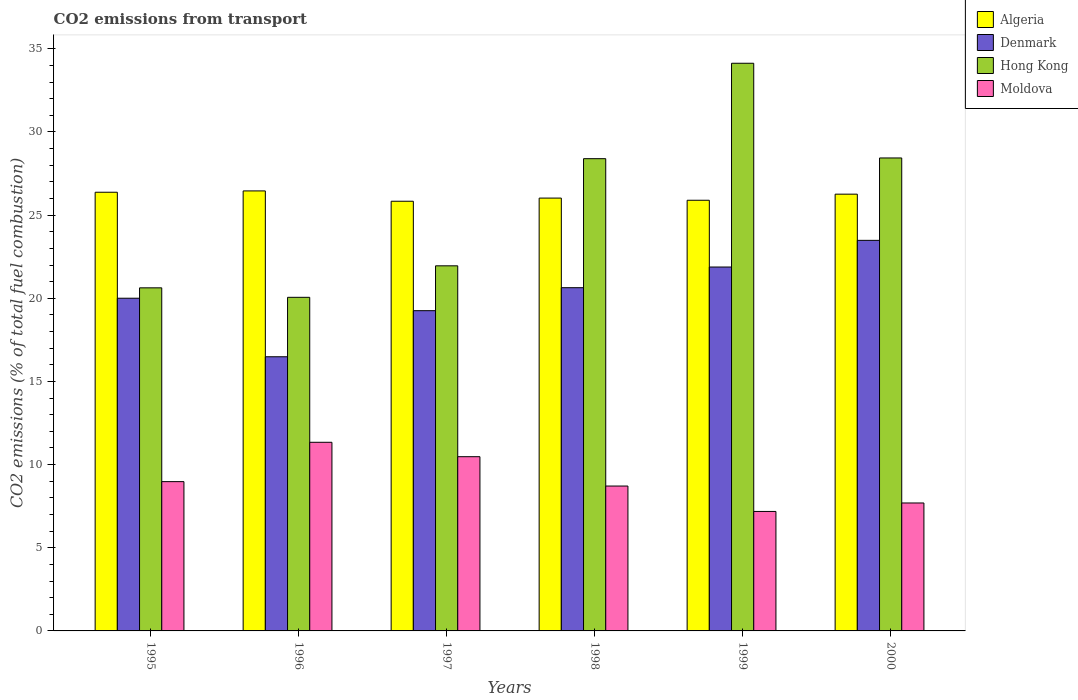How many groups of bars are there?
Your response must be concise. 6. What is the label of the 2nd group of bars from the left?
Offer a terse response. 1996. What is the total CO2 emitted in Algeria in 1999?
Your response must be concise. 25.89. Across all years, what is the maximum total CO2 emitted in Moldova?
Give a very brief answer. 11.34. Across all years, what is the minimum total CO2 emitted in Algeria?
Keep it short and to the point. 25.83. In which year was the total CO2 emitted in Denmark maximum?
Offer a very short reply. 2000. In which year was the total CO2 emitted in Algeria minimum?
Provide a succinct answer. 1997. What is the total total CO2 emitted in Denmark in the graph?
Offer a very short reply. 121.74. What is the difference between the total CO2 emitted in Algeria in 1996 and that in 1997?
Offer a very short reply. 0.62. What is the difference between the total CO2 emitted in Algeria in 1998 and the total CO2 emitted in Denmark in 1997?
Provide a succinct answer. 6.77. What is the average total CO2 emitted in Moldova per year?
Provide a short and direct response. 9.06. In the year 1995, what is the difference between the total CO2 emitted in Algeria and total CO2 emitted in Denmark?
Keep it short and to the point. 6.37. What is the ratio of the total CO2 emitted in Algeria in 1995 to that in 1998?
Your answer should be very brief. 1.01. What is the difference between the highest and the second highest total CO2 emitted in Denmark?
Provide a short and direct response. 1.6. What is the difference between the highest and the lowest total CO2 emitted in Denmark?
Offer a terse response. 7. Is the sum of the total CO2 emitted in Hong Kong in 1995 and 1998 greater than the maximum total CO2 emitted in Algeria across all years?
Provide a short and direct response. Yes. What does the 4th bar from the left in 1995 represents?
Ensure brevity in your answer.  Moldova. What does the 3rd bar from the right in 1999 represents?
Make the answer very short. Denmark. How many bars are there?
Your answer should be very brief. 24. What is the difference between two consecutive major ticks on the Y-axis?
Offer a terse response. 5. Are the values on the major ticks of Y-axis written in scientific E-notation?
Offer a terse response. No. Does the graph contain any zero values?
Offer a terse response. No. Where does the legend appear in the graph?
Your answer should be compact. Top right. How many legend labels are there?
Provide a short and direct response. 4. How are the legend labels stacked?
Give a very brief answer. Vertical. What is the title of the graph?
Offer a terse response. CO2 emissions from transport. Does "Benin" appear as one of the legend labels in the graph?
Keep it short and to the point. No. What is the label or title of the Y-axis?
Ensure brevity in your answer.  CO2 emissions (% of total fuel combustion). What is the CO2 emissions (% of total fuel combustion) in Algeria in 1995?
Provide a short and direct response. 26.38. What is the CO2 emissions (% of total fuel combustion) of Denmark in 1995?
Give a very brief answer. 20. What is the CO2 emissions (% of total fuel combustion) of Hong Kong in 1995?
Ensure brevity in your answer.  20.63. What is the CO2 emissions (% of total fuel combustion) of Moldova in 1995?
Offer a very short reply. 8.98. What is the CO2 emissions (% of total fuel combustion) of Algeria in 1996?
Offer a terse response. 26.45. What is the CO2 emissions (% of total fuel combustion) in Denmark in 1996?
Provide a succinct answer. 16.48. What is the CO2 emissions (% of total fuel combustion) of Hong Kong in 1996?
Offer a very short reply. 20.06. What is the CO2 emissions (% of total fuel combustion) in Moldova in 1996?
Provide a succinct answer. 11.34. What is the CO2 emissions (% of total fuel combustion) in Algeria in 1997?
Ensure brevity in your answer.  25.83. What is the CO2 emissions (% of total fuel combustion) in Denmark in 1997?
Offer a very short reply. 19.25. What is the CO2 emissions (% of total fuel combustion) in Hong Kong in 1997?
Your response must be concise. 21.95. What is the CO2 emissions (% of total fuel combustion) of Moldova in 1997?
Your response must be concise. 10.48. What is the CO2 emissions (% of total fuel combustion) in Algeria in 1998?
Provide a succinct answer. 26.02. What is the CO2 emissions (% of total fuel combustion) in Denmark in 1998?
Your answer should be compact. 20.64. What is the CO2 emissions (% of total fuel combustion) in Hong Kong in 1998?
Give a very brief answer. 28.39. What is the CO2 emissions (% of total fuel combustion) in Moldova in 1998?
Provide a succinct answer. 8.71. What is the CO2 emissions (% of total fuel combustion) in Algeria in 1999?
Provide a succinct answer. 25.89. What is the CO2 emissions (% of total fuel combustion) of Denmark in 1999?
Make the answer very short. 21.88. What is the CO2 emissions (% of total fuel combustion) of Hong Kong in 1999?
Offer a very short reply. 34.13. What is the CO2 emissions (% of total fuel combustion) of Moldova in 1999?
Provide a short and direct response. 7.18. What is the CO2 emissions (% of total fuel combustion) of Algeria in 2000?
Offer a very short reply. 26.26. What is the CO2 emissions (% of total fuel combustion) of Denmark in 2000?
Your answer should be compact. 23.48. What is the CO2 emissions (% of total fuel combustion) in Hong Kong in 2000?
Your response must be concise. 28.44. What is the CO2 emissions (% of total fuel combustion) of Moldova in 2000?
Offer a very short reply. 7.69. Across all years, what is the maximum CO2 emissions (% of total fuel combustion) in Algeria?
Keep it short and to the point. 26.45. Across all years, what is the maximum CO2 emissions (% of total fuel combustion) in Denmark?
Your response must be concise. 23.48. Across all years, what is the maximum CO2 emissions (% of total fuel combustion) in Hong Kong?
Give a very brief answer. 34.13. Across all years, what is the maximum CO2 emissions (% of total fuel combustion) of Moldova?
Your answer should be very brief. 11.34. Across all years, what is the minimum CO2 emissions (% of total fuel combustion) in Algeria?
Offer a very short reply. 25.83. Across all years, what is the minimum CO2 emissions (% of total fuel combustion) in Denmark?
Offer a very short reply. 16.48. Across all years, what is the minimum CO2 emissions (% of total fuel combustion) of Hong Kong?
Your response must be concise. 20.06. Across all years, what is the minimum CO2 emissions (% of total fuel combustion) in Moldova?
Your answer should be very brief. 7.18. What is the total CO2 emissions (% of total fuel combustion) in Algeria in the graph?
Offer a terse response. 156.84. What is the total CO2 emissions (% of total fuel combustion) in Denmark in the graph?
Offer a very short reply. 121.74. What is the total CO2 emissions (% of total fuel combustion) in Hong Kong in the graph?
Give a very brief answer. 153.6. What is the total CO2 emissions (% of total fuel combustion) in Moldova in the graph?
Your answer should be compact. 54.38. What is the difference between the CO2 emissions (% of total fuel combustion) in Algeria in 1995 and that in 1996?
Your answer should be very brief. -0.08. What is the difference between the CO2 emissions (% of total fuel combustion) in Denmark in 1995 and that in 1996?
Offer a very short reply. 3.52. What is the difference between the CO2 emissions (% of total fuel combustion) of Hong Kong in 1995 and that in 1996?
Your response must be concise. 0.57. What is the difference between the CO2 emissions (% of total fuel combustion) in Moldova in 1995 and that in 1996?
Keep it short and to the point. -2.37. What is the difference between the CO2 emissions (% of total fuel combustion) of Algeria in 1995 and that in 1997?
Make the answer very short. 0.54. What is the difference between the CO2 emissions (% of total fuel combustion) in Denmark in 1995 and that in 1997?
Your answer should be compact. 0.75. What is the difference between the CO2 emissions (% of total fuel combustion) in Hong Kong in 1995 and that in 1997?
Make the answer very short. -1.32. What is the difference between the CO2 emissions (% of total fuel combustion) in Moldova in 1995 and that in 1997?
Keep it short and to the point. -1.5. What is the difference between the CO2 emissions (% of total fuel combustion) in Algeria in 1995 and that in 1998?
Offer a terse response. 0.35. What is the difference between the CO2 emissions (% of total fuel combustion) of Denmark in 1995 and that in 1998?
Provide a succinct answer. -0.63. What is the difference between the CO2 emissions (% of total fuel combustion) in Hong Kong in 1995 and that in 1998?
Ensure brevity in your answer.  -7.77. What is the difference between the CO2 emissions (% of total fuel combustion) of Moldova in 1995 and that in 1998?
Offer a terse response. 0.26. What is the difference between the CO2 emissions (% of total fuel combustion) of Algeria in 1995 and that in 1999?
Your answer should be very brief. 0.48. What is the difference between the CO2 emissions (% of total fuel combustion) in Denmark in 1995 and that in 1999?
Your response must be concise. -1.88. What is the difference between the CO2 emissions (% of total fuel combustion) of Hong Kong in 1995 and that in 1999?
Your answer should be very brief. -13.5. What is the difference between the CO2 emissions (% of total fuel combustion) in Moldova in 1995 and that in 1999?
Provide a succinct answer. 1.79. What is the difference between the CO2 emissions (% of total fuel combustion) of Algeria in 1995 and that in 2000?
Provide a succinct answer. 0.12. What is the difference between the CO2 emissions (% of total fuel combustion) of Denmark in 1995 and that in 2000?
Your answer should be compact. -3.48. What is the difference between the CO2 emissions (% of total fuel combustion) in Hong Kong in 1995 and that in 2000?
Give a very brief answer. -7.81. What is the difference between the CO2 emissions (% of total fuel combustion) of Moldova in 1995 and that in 2000?
Offer a very short reply. 1.28. What is the difference between the CO2 emissions (% of total fuel combustion) of Algeria in 1996 and that in 1997?
Make the answer very short. 0.62. What is the difference between the CO2 emissions (% of total fuel combustion) in Denmark in 1996 and that in 1997?
Offer a terse response. -2.77. What is the difference between the CO2 emissions (% of total fuel combustion) in Hong Kong in 1996 and that in 1997?
Make the answer very short. -1.89. What is the difference between the CO2 emissions (% of total fuel combustion) of Moldova in 1996 and that in 1997?
Make the answer very short. 0.87. What is the difference between the CO2 emissions (% of total fuel combustion) of Algeria in 1996 and that in 1998?
Make the answer very short. 0.43. What is the difference between the CO2 emissions (% of total fuel combustion) in Denmark in 1996 and that in 1998?
Provide a short and direct response. -4.15. What is the difference between the CO2 emissions (% of total fuel combustion) in Hong Kong in 1996 and that in 1998?
Make the answer very short. -8.34. What is the difference between the CO2 emissions (% of total fuel combustion) in Moldova in 1996 and that in 1998?
Your answer should be compact. 2.63. What is the difference between the CO2 emissions (% of total fuel combustion) of Algeria in 1996 and that in 1999?
Offer a very short reply. 0.56. What is the difference between the CO2 emissions (% of total fuel combustion) in Denmark in 1996 and that in 1999?
Make the answer very short. -5.39. What is the difference between the CO2 emissions (% of total fuel combustion) of Hong Kong in 1996 and that in 1999?
Ensure brevity in your answer.  -14.07. What is the difference between the CO2 emissions (% of total fuel combustion) in Moldova in 1996 and that in 1999?
Your answer should be compact. 4.16. What is the difference between the CO2 emissions (% of total fuel combustion) in Algeria in 1996 and that in 2000?
Your answer should be very brief. 0.2. What is the difference between the CO2 emissions (% of total fuel combustion) of Denmark in 1996 and that in 2000?
Your answer should be compact. -7. What is the difference between the CO2 emissions (% of total fuel combustion) of Hong Kong in 1996 and that in 2000?
Your answer should be very brief. -8.38. What is the difference between the CO2 emissions (% of total fuel combustion) of Moldova in 1996 and that in 2000?
Provide a short and direct response. 3.65. What is the difference between the CO2 emissions (% of total fuel combustion) of Algeria in 1997 and that in 1998?
Offer a very short reply. -0.19. What is the difference between the CO2 emissions (% of total fuel combustion) of Denmark in 1997 and that in 1998?
Offer a terse response. -1.38. What is the difference between the CO2 emissions (% of total fuel combustion) of Hong Kong in 1997 and that in 1998?
Make the answer very short. -6.44. What is the difference between the CO2 emissions (% of total fuel combustion) in Moldova in 1997 and that in 1998?
Provide a short and direct response. 1.76. What is the difference between the CO2 emissions (% of total fuel combustion) of Algeria in 1997 and that in 1999?
Make the answer very short. -0.06. What is the difference between the CO2 emissions (% of total fuel combustion) of Denmark in 1997 and that in 1999?
Make the answer very short. -2.62. What is the difference between the CO2 emissions (% of total fuel combustion) of Hong Kong in 1997 and that in 1999?
Make the answer very short. -12.18. What is the difference between the CO2 emissions (% of total fuel combustion) in Moldova in 1997 and that in 1999?
Make the answer very short. 3.29. What is the difference between the CO2 emissions (% of total fuel combustion) of Algeria in 1997 and that in 2000?
Give a very brief answer. -0.43. What is the difference between the CO2 emissions (% of total fuel combustion) in Denmark in 1997 and that in 2000?
Ensure brevity in your answer.  -4.23. What is the difference between the CO2 emissions (% of total fuel combustion) of Hong Kong in 1997 and that in 2000?
Ensure brevity in your answer.  -6.49. What is the difference between the CO2 emissions (% of total fuel combustion) of Moldova in 1997 and that in 2000?
Provide a succinct answer. 2.78. What is the difference between the CO2 emissions (% of total fuel combustion) in Algeria in 1998 and that in 1999?
Give a very brief answer. 0.13. What is the difference between the CO2 emissions (% of total fuel combustion) in Denmark in 1998 and that in 1999?
Provide a succinct answer. -1.24. What is the difference between the CO2 emissions (% of total fuel combustion) of Hong Kong in 1998 and that in 1999?
Your response must be concise. -5.74. What is the difference between the CO2 emissions (% of total fuel combustion) in Moldova in 1998 and that in 1999?
Your answer should be compact. 1.53. What is the difference between the CO2 emissions (% of total fuel combustion) in Algeria in 1998 and that in 2000?
Offer a terse response. -0.24. What is the difference between the CO2 emissions (% of total fuel combustion) in Denmark in 1998 and that in 2000?
Your answer should be compact. -2.85. What is the difference between the CO2 emissions (% of total fuel combustion) in Hong Kong in 1998 and that in 2000?
Offer a terse response. -0.04. What is the difference between the CO2 emissions (% of total fuel combustion) in Moldova in 1998 and that in 2000?
Give a very brief answer. 1.02. What is the difference between the CO2 emissions (% of total fuel combustion) of Algeria in 1999 and that in 2000?
Offer a very short reply. -0.37. What is the difference between the CO2 emissions (% of total fuel combustion) of Denmark in 1999 and that in 2000?
Your answer should be very brief. -1.6. What is the difference between the CO2 emissions (% of total fuel combustion) of Hong Kong in 1999 and that in 2000?
Offer a very short reply. 5.69. What is the difference between the CO2 emissions (% of total fuel combustion) in Moldova in 1999 and that in 2000?
Your response must be concise. -0.51. What is the difference between the CO2 emissions (% of total fuel combustion) in Algeria in 1995 and the CO2 emissions (% of total fuel combustion) in Denmark in 1996?
Make the answer very short. 9.89. What is the difference between the CO2 emissions (% of total fuel combustion) in Algeria in 1995 and the CO2 emissions (% of total fuel combustion) in Hong Kong in 1996?
Offer a terse response. 6.32. What is the difference between the CO2 emissions (% of total fuel combustion) of Algeria in 1995 and the CO2 emissions (% of total fuel combustion) of Moldova in 1996?
Give a very brief answer. 15.03. What is the difference between the CO2 emissions (% of total fuel combustion) of Denmark in 1995 and the CO2 emissions (% of total fuel combustion) of Hong Kong in 1996?
Provide a short and direct response. -0.05. What is the difference between the CO2 emissions (% of total fuel combustion) of Denmark in 1995 and the CO2 emissions (% of total fuel combustion) of Moldova in 1996?
Your response must be concise. 8.66. What is the difference between the CO2 emissions (% of total fuel combustion) of Hong Kong in 1995 and the CO2 emissions (% of total fuel combustion) of Moldova in 1996?
Offer a terse response. 9.29. What is the difference between the CO2 emissions (% of total fuel combustion) in Algeria in 1995 and the CO2 emissions (% of total fuel combustion) in Denmark in 1997?
Ensure brevity in your answer.  7.12. What is the difference between the CO2 emissions (% of total fuel combustion) in Algeria in 1995 and the CO2 emissions (% of total fuel combustion) in Hong Kong in 1997?
Provide a short and direct response. 4.42. What is the difference between the CO2 emissions (% of total fuel combustion) in Denmark in 1995 and the CO2 emissions (% of total fuel combustion) in Hong Kong in 1997?
Provide a succinct answer. -1.95. What is the difference between the CO2 emissions (% of total fuel combustion) of Denmark in 1995 and the CO2 emissions (% of total fuel combustion) of Moldova in 1997?
Ensure brevity in your answer.  9.53. What is the difference between the CO2 emissions (% of total fuel combustion) in Hong Kong in 1995 and the CO2 emissions (% of total fuel combustion) in Moldova in 1997?
Offer a terse response. 10.15. What is the difference between the CO2 emissions (% of total fuel combustion) of Algeria in 1995 and the CO2 emissions (% of total fuel combustion) of Denmark in 1998?
Provide a short and direct response. 5.74. What is the difference between the CO2 emissions (% of total fuel combustion) in Algeria in 1995 and the CO2 emissions (% of total fuel combustion) in Hong Kong in 1998?
Provide a short and direct response. -2.02. What is the difference between the CO2 emissions (% of total fuel combustion) in Algeria in 1995 and the CO2 emissions (% of total fuel combustion) in Moldova in 1998?
Give a very brief answer. 17.66. What is the difference between the CO2 emissions (% of total fuel combustion) of Denmark in 1995 and the CO2 emissions (% of total fuel combustion) of Hong Kong in 1998?
Give a very brief answer. -8.39. What is the difference between the CO2 emissions (% of total fuel combustion) of Denmark in 1995 and the CO2 emissions (% of total fuel combustion) of Moldova in 1998?
Provide a short and direct response. 11.29. What is the difference between the CO2 emissions (% of total fuel combustion) of Hong Kong in 1995 and the CO2 emissions (% of total fuel combustion) of Moldova in 1998?
Ensure brevity in your answer.  11.92. What is the difference between the CO2 emissions (% of total fuel combustion) in Algeria in 1995 and the CO2 emissions (% of total fuel combustion) in Denmark in 1999?
Keep it short and to the point. 4.5. What is the difference between the CO2 emissions (% of total fuel combustion) of Algeria in 1995 and the CO2 emissions (% of total fuel combustion) of Hong Kong in 1999?
Give a very brief answer. -7.76. What is the difference between the CO2 emissions (% of total fuel combustion) in Algeria in 1995 and the CO2 emissions (% of total fuel combustion) in Moldova in 1999?
Your answer should be very brief. 19.19. What is the difference between the CO2 emissions (% of total fuel combustion) in Denmark in 1995 and the CO2 emissions (% of total fuel combustion) in Hong Kong in 1999?
Provide a succinct answer. -14.13. What is the difference between the CO2 emissions (% of total fuel combustion) of Denmark in 1995 and the CO2 emissions (% of total fuel combustion) of Moldova in 1999?
Provide a succinct answer. 12.82. What is the difference between the CO2 emissions (% of total fuel combustion) in Hong Kong in 1995 and the CO2 emissions (% of total fuel combustion) in Moldova in 1999?
Your response must be concise. 13.44. What is the difference between the CO2 emissions (% of total fuel combustion) in Algeria in 1995 and the CO2 emissions (% of total fuel combustion) in Denmark in 2000?
Your response must be concise. 2.89. What is the difference between the CO2 emissions (% of total fuel combustion) of Algeria in 1995 and the CO2 emissions (% of total fuel combustion) of Hong Kong in 2000?
Provide a short and direct response. -2.06. What is the difference between the CO2 emissions (% of total fuel combustion) in Algeria in 1995 and the CO2 emissions (% of total fuel combustion) in Moldova in 2000?
Ensure brevity in your answer.  18.68. What is the difference between the CO2 emissions (% of total fuel combustion) of Denmark in 1995 and the CO2 emissions (% of total fuel combustion) of Hong Kong in 2000?
Provide a short and direct response. -8.43. What is the difference between the CO2 emissions (% of total fuel combustion) of Denmark in 1995 and the CO2 emissions (% of total fuel combustion) of Moldova in 2000?
Your answer should be compact. 12.31. What is the difference between the CO2 emissions (% of total fuel combustion) in Hong Kong in 1995 and the CO2 emissions (% of total fuel combustion) in Moldova in 2000?
Provide a short and direct response. 12.94. What is the difference between the CO2 emissions (% of total fuel combustion) of Algeria in 1996 and the CO2 emissions (% of total fuel combustion) of Denmark in 1997?
Ensure brevity in your answer.  7.2. What is the difference between the CO2 emissions (% of total fuel combustion) in Algeria in 1996 and the CO2 emissions (% of total fuel combustion) in Hong Kong in 1997?
Ensure brevity in your answer.  4.5. What is the difference between the CO2 emissions (% of total fuel combustion) in Algeria in 1996 and the CO2 emissions (% of total fuel combustion) in Moldova in 1997?
Your answer should be compact. 15.98. What is the difference between the CO2 emissions (% of total fuel combustion) in Denmark in 1996 and the CO2 emissions (% of total fuel combustion) in Hong Kong in 1997?
Your answer should be very brief. -5.47. What is the difference between the CO2 emissions (% of total fuel combustion) of Denmark in 1996 and the CO2 emissions (% of total fuel combustion) of Moldova in 1997?
Offer a very short reply. 6.01. What is the difference between the CO2 emissions (% of total fuel combustion) in Hong Kong in 1996 and the CO2 emissions (% of total fuel combustion) in Moldova in 1997?
Ensure brevity in your answer.  9.58. What is the difference between the CO2 emissions (% of total fuel combustion) of Algeria in 1996 and the CO2 emissions (% of total fuel combustion) of Denmark in 1998?
Your answer should be very brief. 5.82. What is the difference between the CO2 emissions (% of total fuel combustion) of Algeria in 1996 and the CO2 emissions (% of total fuel combustion) of Hong Kong in 1998?
Provide a succinct answer. -1.94. What is the difference between the CO2 emissions (% of total fuel combustion) in Algeria in 1996 and the CO2 emissions (% of total fuel combustion) in Moldova in 1998?
Your response must be concise. 17.74. What is the difference between the CO2 emissions (% of total fuel combustion) in Denmark in 1996 and the CO2 emissions (% of total fuel combustion) in Hong Kong in 1998?
Offer a very short reply. -11.91. What is the difference between the CO2 emissions (% of total fuel combustion) in Denmark in 1996 and the CO2 emissions (% of total fuel combustion) in Moldova in 1998?
Offer a very short reply. 7.77. What is the difference between the CO2 emissions (% of total fuel combustion) of Hong Kong in 1996 and the CO2 emissions (% of total fuel combustion) of Moldova in 1998?
Give a very brief answer. 11.35. What is the difference between the CO2 emissions (% of total fuel combustion) in Algeria in 1996 and the CO2 emissions (% of total fuel combustion) in Denmark in 1999?
Provide a short and direct response. 4.58. What is the difference between the CO2 emissions (% of total fuel combustion) in Algeria in 1996 and the CO2 emissions (% of total fuel combustion) in Hong Kong in 1999?
Make the answer very short. -7.68. What is the difference between the CO2 emissions (% of total fuel combustion) of Algeria in 1996 and the CO2 emissions (% of total fuel combustion) of Moldova in 1999?
Provide a short and direct response. 19.27. What is the difference between the CO2 emissions (% of total fuel combustion) in Denmark in 1996 and the CO2 emissions (% of total fuel combustion) in Hong Kong in 1999?
Keep it short and to the point. -17.65. What is the difference between the CO2 emissions (% of total fuel combustion) in Denmark in 1996 and the CO2 emissions (% of total fuel combustion) in Moldova in 1999?
Provide a succinct answer. 9.3. What is the difference between the CO2 emissions (% of total fuel combustion) of Hong Kong in 1996 and the CO2 emissions (% of total fuel combustion) of Moldova in 1999?
Provide a short and direct response. 12.87. What is the difference between the CO2 emissions (% of total fuel combustion) of Algeria in 1996 and the CO2 emissions (% of total fuel combustion) of Denmark in 2000?
Keep it short and to the point. 2.97. What is the difference between the CO2 emissions (% of total fuel combustion) of Algeria in 1996 and the CO2 emissions (% of total fuel combustion) of Hong Kong in 2000?
Give a very brief answer. -1.98. What is the difference between the CO2 emissions (% of total fuel combustion) of Algeria in 1996 and the CO2 emissions (% of total fuel combustion) of Moldova in 2000?
Your answer should be compact. 18.76. What is the difference between the CO2 emissions (% of total fuel combustion) in Denmark in 1996 and the CO2 emissions (% of total fuel combustion) in Hong Kong in 2000?
Ensure brevity in your answer.  -11.95. What is the difference between the CO2 emissions (% of total fuel combustion) of Denmark in 1996 and the CO2 emissions (% of total fuel combustion) of Moldova in 2000?
Ensure brevity in your answer.  8.79. What is the difference between the CO2 emissions (% of total fuel combustion) of Hong Kong in 1996 and the CO2 emissions (% of total fuel combustion) of Moldova in 2000?
Offer a very short reply. 12.37. What is the difference between the CO2 emissions (% of total fuel combustion) in Algeria in 1997 and the CO2 emissions (% of total fuel combustion) in Denmark in 1998?
Provide a short and direct response. 5.2. What is the difference between the CO2 emissions (% of total fuel combustion) in Algeria in 1997 and the CO2 emissions (% of total fuel combustion) in Hong Kong in 1998?
Your answer should be very brief. -2.56. What is the difference between the CO2 emissions (% of total fuel combustion) in Algeria in 1997 and the CO2 emissions (% of total fuel combustion) in Moldova in 1998?
Make the answer very short. 17.12. What is the difference between the CO2 emissions (% of total fuel combustion) of Denmark in 1997 and the CO2 emissions (% of total fuel combustion) of Hong Kong in 1998?
Your answer should be compact. -9.14. What is the difference between the CO2 emissions (% of total fuel combustion) of Denmark in 1997 and the CO2 emissions (% of total fuel combustion) of Moldova in 1998?
Make the answer very short. 10.54. What is the difference between the CO2 emissions (% of total fuel combustion) in Hong Kong in 1997 and the CO2 emissions (% of total fuel combustion) in Moldova in 1998?
Offer a very short reply. 13.24. What is the difference between the CO2 emissions (% of total fuel combustion) of Algeria in 1997 and the CO2 emissions (% of total fuel combustion) of Denmark in 1999?
Your answer should be very brief. 3.95. What is the difference between the CO2 emissions (% of total fuel combustion) in Algeria in 1997 and the CO2 emissions (% of total fuel combustion) in Hong Kong in 1999?
Ensure brevity in your answer.  -8.3. What is the difference between the CO2 emissions (% of total fuel combustion) in Algeria in 1997 and the CO2 emissions (% of total fuel combustion) in Moldova in 1999?
Your answer should be compact. 18.65. What is the difference between the CO2 emissions (% of total fuel combustion) in Denmark in 1997 and the CO2 emissions (% of total fuel combustion) in Hong Kong in 1999?
Provide a succinct answer. -14.88. What is the difference between the CO2 emissions (% of total fuel combustion) of Denmark in 1997 and the CO2 emissions (% of total fuel combustion) of Moldova in 1999?
Your answer should be compact. 12.07. What is the difference between the CO2 emissions (% of total fuel combustion) in Hong Kong in 1997 and the CO2 emissions (% of total fuel combustion) in Moldova in 1999?
Provide a short and direct response. 14.77. What is the difference between the CO2 emissions (% of total fuel combustion) in Algeria in 1997 and the CO2 emissions (% of total fuel combustion) in Denmark in 2000?
Provide a short and direct response. 2.35. What is the difference between the CO2 emissions (% of total fuel combustion) in Algeria in 1997 and the CO2 emissions (% of total fuel combustion) in Hong Kong in 2000?
Provide a short and direct response. -2.6. What is the difference between the CO2 emissions (% of total fuel combustion) in Algeria in 1997 and the CO2 emissions (% of total fuel combustion) in Moldova in 2000?
Ensure brevity in your answer.  18.14. What is the difference between the CO2 emissions (% of total fuel combustion) in Denmark in 1997 and the CO2 emissions (% of total fuel combustion) in Hong Kong in 2000?
Ensure brevity in your answer.  -9.18. What is the difference between the CO2 emissions (% of total fuel combustion) in Denmark in 1997 and the CO2 emissions (% of total fuel combustion) in Moldova in 2000?
Provide a succinct answer. 11.56. What is the difference between the CO2 emissions (% of total fuel combustion) of Hong Kong in 1997 and the CO2 emissions (% of total fuel combustion) of Moldova in 2000?
Offer a terse response. 14.26. What is the difference between the CO2 emissions (% of total fuel combustion) in Algeria in 1998 and the CO2 emissions (% of total fuel combustion) in Denmark in 1999?
Ensure brevity in your answer.  4.15. What is the difference between the CO2 emissions (% of total fuel combustion) in Algeria in 1998 and the CO2 emissions (% of total fuel combustion) in Hong Kong in 1999?
Your answer should be compact. -8.11. What is the difference between the CO2 emissions (% of total fuel combustion) of Algeria in 1998 and the CO2 emissions (% of total fuel combustion) of Moldova in 1999?
Make the answer very short. 18.84. What is the difference between the CO2 emissions (% of total fuel combustion) in Denmark in 1998 and the CO2 emissions (% of total fuel combustion) in Hong Kong in 1999?
Provide a short and direct response. -13.49. What is the difference between the CO2 emissions (% of total fuel combustion) in Denmark in 1998 and the CO2 emissions (% of total fuel combustion) in Moldova in 1999?
Provide a succinct answer. 13.45. What is the difference between the CO2 emissions (% of total fuel combustion) in Hong Kong in 1998 and the CO2 emissions (% of total fuel combustion) in Moldova in 1999?
Offer a very short reply. 21.21. What is the difference between the CO2 emissions (% of total fuel combustion) in Algeria in 1998 and the CO2 emissions (% of total fuel combustion) in Denmark in 2000?
Your answer should be compact. 2.54. What is the difference between the CO2 emissions (% of total fuel combustion) of Algeria in 1998 and the CO2 emissions (% of total fuel combustion) of Hong Kong in 2000?
Offer a very short reply. -2.41. What is the difference between the CO2 emissions (% of total fuel combustion) in Algeria in 1998 and the CO2 emissions (% of total fuel combustion) in Moldova in 2000?
Keep it short and to the point. 18.33. What is the difference between the CO2 emissions (% of total fuel combustion) in Denmark in 1998 and the CO2 emissions (% of total fuel combustion) in Hong Kong in 2000?
Ensure brevity in your answer.  -7.8. What is the difference between the CO2 emissions (% of total fuel combustion) in Denmark in 1998 and the CO2 emissions (% of total fuel combustion) in Moldova in 2000?
Give a very brief answer. 12.94. What is the difference between the CO2 emissions (% of total fuel combustion) in Hong Kong in 1998 and the CO2 emissions (% of total fuel combustion) in Moldova in 2000?
Keep it short and to the point. 20.7. What is the difference between the CO2 emissions (% of total fuel combustion) in Algeria in 1999 and the CO2 emissions (% of total fuel combustion) in Denmark in 2000?
Your response must be concise. 2.41. What is the difference between the CO2 emissions (% of total fuel combustion) of Algeria in 1999 and the CO2 emissions (% of total fuel combustion) of Hong Kong in 2000?
Offer a terse response. -2.54. What is the difference between the CO2 emissions (% of total fuel combustion) of Algeria in 1999 and the CO2 emissions (% of total fuel combustion) of Moldova in 2000?
Your response must be concise. 18.2. What is the difference between the CO2 emissions (% of total fuel combustion) in Denmark in 1999 and the CO2 emissions (% of total fuel combustion) in Hong Kong in 2000?
Your response must be concise. -6.56. What is the difference between the CO2 emissions (% of total fuel combustion) of Denmark in 1999 and the CO2 emissions (% of total fuel combustion) of Moldova in 2000?
Your answer should be compact. 14.19. What is the difference between the CO2 emissions (% of total fuel combustion) of Hong Kong in 1999 and the CO2 emissions (% of total fuel combustion) of Moldova in 2000?
Provide a succinct answer. 26.44. What is the average CO2 emissions (% of total fuel combustion) in Algeria per year?
Your answer should be compact. 26.14. What is the average CO2 emissions (% of total fuel combustion) of Denmark per year?
Your answer should be very brief. 20.29. What is the average CO2 emissions (% of total fuel combustion) of Hong Kong per year?
Your answer should be very brief. 25.6. What is the average CO2 emissions (% of total fuel combustion) in Moldova per year?
Make the answer very short. 9.06. In the year 1995, what is the difference between the CO2 emissions (% of total fuel combustion) in Algeria and CO2 emissions (% of total fuel combustion) in Denmark?
Give a very brief answer. 6.37. In the year 1995, what is the difference between the CO2 emissions (% of total fuel combustion) of Algeria and CO2 emissions (% of total fuel combustion) of Hong Kong?
Your answer should be compact. 5.75. In the year 1995, what is the difference between the CO2 emissions (% of total fuel combustion) of Algeria and CO2 emissions (% of total fuel combustion) of Moldova?
Offer a terse response. 17.4. In the year 1995, what is the difference between the CO2 emissions (% of total fuel combustion) of Denmark and CO2 emissions (% of total fuel combustion) of Hong Kong?
Keep it short and to the point. -0.62. In the year 1995, what is the difference between the CO2 emissions (% of total fuel combustion) of Denmark and CO2 emissions (% of total fuel combustion) of Moldova?
Provide a succinct answer. 11.03. In the year 1995, what is the difference between the CO2 emissions (% of total fuel combustion) in Hong Kong and CO2 emissions (% of total fuel combustion) in Moldova?
Offer a very short reply. 11.65. In the year 1996, what is the difference between the CO2 emissions (% of total fuel combustion) of Algeria and CO2 emissions (% of total fuel combustion) of Denmark?
Offer a very short reply. 9.97. In the year 1996, what is the difference between the CO2 emissions (% of total fuel combustion) of Algeria and CO2 emissions (% of total fuel combustion) of Hong Kong?
Ensure brevity in your answer.  6.4. In the year 1996, what is the difference between the CO2 emissions (% of total fuel combustion) of Algeria and CO2 emissions (% of total fuel combustion) of Moldova?
Keep it short and to the point. 15.11. In the year 1996, what is the difference between the CO2 emissions (% of total fuel combustion) in Denmark and CO2 emissions (% of total fuel combustion) in Hong Kong?
Offer a very short reply. -3.57. In the year 1996, what is the difference between the CO2 emissions (% of total fuel combustion) of Denmark and CO2 emissions (% of total fuel combustion) of Moldova?
Provide a short and direct response. 5.14. In the year 1996, what is the difference between the CO2 emissions (% of total fuel combustion) of Hong Kong and CO2 emissions (% of total fuel combustion) of Moldova?
Provide a succinct answer. 8.72. In the year 1997, what is the difference between the CO2 emissions (% of total fuel combustion) of Algeria and CO2 emissions (% of total fuel combustion) of Denmark?
Make the answer very short. 6.58. In the year 1997, what is the difference between the CO2 emissions (% of total fuel combustion) in Algeria and CO2 emissions (% of total fuel combustion) in Hong Kong?
Offer a terse response. 3.88. In the year 1997, what is the difference between the CO2 emissions (% of total fuel combustion) of Algeria and CO2 emissions (% of total fuel combustion) of Moldova?
Make the answer very short. 15.36. In the year 1997, what is the difference between the CO2 emissions (% of total fuel combustion) of Denmark and CO2 emissions (% of total fuel combustion) of Hong Kong?
Your answer should be very brief. -2.7. In the year 1997, what is the difference between the CO2 emissions (% of total fuel combustion) of Denmark and CO2 emissions (% of total fuel combustion) of Moldova?
Make the answer very short. 8.78. In the year 1997, what is the difference between the CO2 emissions (% of total fuel combustion) of Hong Kong and CO2 emissions (% of total fuel combustion) of Moldova?
Offer a terse response. 11.48. In the year 1998, what is the difference between the CO2 emissions (% of total fuel combustion) in Algeria and CO2 emissions (% of total fuel combustion) in Denmark?
Ensure brevity in your answer.  5.39. In the year 1998, what is the difference between the CO2 emissions (% of total fuel combustion) in Algeria and CO2 emissions (% of total fuel combustion) in Hong Kong?
Offer a terse response. -2.37. In the year 1998, what is the difference between the CO2 emissions (% of total fuel combustion) in Algeria and CO2 emissions (% of total fuel combustion) in Moldova?
Your response must be concise. 17.31. In the year 1998, what is the difference between the CO2 emissions (% of total fuel combustion) in Denmark and CO2 emissions (% of total fuel combustion) in Hong Kong?
Provide a succinct answer. -7.76. In the year 1998, what is the difference between the CO2 emissions (% of total fuel combustion) in Denmark and CO2 emissions (% of total fuel combustion) in Moldova?
Keep it short and to the point. 11.93. In the year 1998, what is the difference between the CO2 emissions (% of total fuel combustion) of Hong Kong and CO2 emissions (% of total fuel combustion) of Moldova?
Offer a very short reply. 19.68. In the year 1999, what is the difference between the CO2 emissions (% of total fuel combustion) of Algeria and CO2 emissions (% of total fuel combustion) of Denmark?
Provide a succinct answer. 4.01. In the year 1999, what is the difference between the CO2 emissions (% of total fuel combustion) in Algeria and CO2 emissions (% of total fuel combustion) in Hong Kong?
Your answer should be very brief. -8.24. In the year 1999, what is the difference between the CO2 emissions (% of total fuel combustion) in Algeria and CO2 emissions (% of total fuel combustion) in Moldova?
Offer a terse response. 18.71. In the year 1999, what is the difference between the CO2 emissions (% of total fuel combustion) of Denmark and CO2 emissions (% of total fuel combustion) of Hong Kong?
Keep it short and to the point. -12.25. In the year 1999, what is the difference between the CO2 emissions (% of total fuel combustion) in Denmark and CO2 emissions (% of total fuel combustion) in Moldova?
Offer a terse response. 14.7. In the year 1999, what is the difference between the CO2 emissions (% of total fuel combustion) of Hong Kong and CO2 emissions (% of total fuel combustion) of Moldova?
Provide a succinct answer. 26.95. In the year 2000, what is the difference between the CO2 emissions (% of total fuel combustion) of Algeria and CO2 emissions (% of total fuel combustion) of Denmark?
Ensure brevity in your answer.  2.78. In the year 2000, what is the difference between the CO2 emissions (% of total fuel combustion) in Algeria and CO2 emissions (% of total fuel combustion) in Hong Kong?
Offer a very short reply. -2.18. In the year 2000, what is the difference between the CO2 emissions (% of total fuel combustion) of Algeria and CO2 emissions (% of total fuel combustion) of Moldova?
Make the answer very short. 18.57. In the year 2000, what is the difference between the CO2 emissions (% of total fuel combustion) in Denmark and CO2 emissions (% of total fuel combustion) in Hong Kong?
Offer a very short reply. -4.95. In the year 2000, what is the difference between the CO2 emissions (% of total fuel combustion) in Denmark and CO2 emissions (% of total fuel combustion) in Moldova?
Give a very brief answer. 15.79. In the year 2000, what is the difference between the CO2 emissions (% of total fuel combustion) in Hong Kong and CO2 emissions (% of total fuel combustion) in Moldova?
Ensure brevity in your answer.  20.74. What is the ratio of the CO2 emissions (% of total fuel combustion) in Algeria in 1995 to that in 1996?
Your response must be concise. 1. What is the ratio of the CO2 emissions (% of total fuel combustion) of Denmark in 1995 to that in 1996?
Your response must be concise. 1.21. What is the ratio of the CO2 emissions (% of total fuel combustion) of Hong Kong in 1995 to that in 1996?
Your answer should be compact. 1.03. What is the ratio of the CO2 emissions (% of total fuel combustion) in Moldova in 1995 to that in 1996?
Your answer should be very brief. 0.79. What is the ratio of the CO2 emissions (% of total fuel combustion) in Denmark in 1995 to that in 1997?
Provide a succinct answer. 1.04. What is the ratio of the CO2 emissions (% of total fuel combustion) of Hong Kong in 1995 to that in 1997?
Give a very brief answer. 0.94. What is the ratio of the CO2 emissions (% of total fuel combustion) in Moldova in 1995 to that in 1997?
Your answer should be compact. 0.86. What is the ratio of the CO2 emissions (% of total fuel combustion) in Algeria in 1995 to that in 1998?
Provide a short and direct response. 1.01. What is the ratio of the CO2 emissions (% of total fuel combustion) in Denmark in 1995 to that in 1998?
Offer a terse response. 0.97. What is the ratio of the CO2 emissions (% of total fuel combustion) of Hong Kong in 1995 to that in 1998?
Offer a terse response. 0.73. What is the ratio of the CO2 emissions (% of total fuel combustion) in Moldova in 1995 to that in 1998?
Your answer should be compact. 1.03. What is the ratio of the CO2 emissions (% of total fuel combustion) of Algeria in 1995 to that in 1999?
Your answer should be compact. 1.02. What is the ratio of the CO2 emissions (% of total fuel combustion) in Denmark in 1995 to that in 1999?
Keep it short and to the point. 0.91. What is the ratio of the CO2 emissions (% of total fuel combustion) of Hong Kong in 1995 to that in 1999?
Ensure brevity in your answer.  0.6. What is the ratio of the CO2 emissions (% of total fuel combustion) in Moldova in 1995 to that in 1999?
Keep it short and to the point. 1.25. What is the ratio of the CO2 emissions (% of total fuel combustion) in Algeria in 1995 to that in 2000?
Your response must be concise. 1. What is the ratio of the CO2 emissions (% of total fuel combustion) in Denmark in 1995 to that in 2000?
Keep it short and to the point. 0.85. What is the ratio of the CO2 emissions (% of total fuel combustion) of Hong Kong in 1995 to that in 2000?
Provide a succinct answer. 0.73. What is the ratio of the CO2 emissions (% of total fuel combustion) in Moldova in 1995 to that in 2000?
Your answer should be very brief. 1.17. What is the ratio of the CO2 emissions (% of total fuel combustion) in Denmark in 1996 to that in 1997?
Offer a very short reply. 0.86. What is the ratio of the CO2 emissions (% of total fuel combustion) of Hong Kong in 1996 to that in 1997?
Offer a terse response. 0.91. What is the ratio of the CO2 emissions (% of total fuel combustion) of Moldova in 1996 to that in 1997?
Give a very brief answer. 1.08. What is the ratio of the CO2 emissions (% of total fuel combustion) in Algeria in 1996 to that in 1998?
Your response must be concise. 1.02. What is the ratio of the CO2 emissions (% of total fuel combustion) of Denmark in 1996 to that in 1998?
Provide a short and direct response. 0.8. What is the ratio of the CO2 emissions (% of total fuel combustion) of Hong Kong in 1996 to that in 1998?
Provide a short and direct response. 0.71. What is the ratio of the CO2 emissions (% of total fuel combustion) in Moldova in 1996 to that in 1998?
Offer a terse response. 1.3. What is the ratio of the CO2 emissions (% of total fuel combustion) of Algeria in 1996 to that in 1999?
Your response must be concise. 1.02. What is the ratio of the CO2 emissions (% of total fuel combustion) in Denmark in 1996 to that in 1999?
Your response must be concise. 0.75. What is the ratio of the CO2 emissions (% of total fuel combustion) in Hong Kong in 1996 to that in 1999?
Give a very brief answer. 0.59. What is the ratio of the CO2 emissions (% of total fuel combustion) in Moldova in 1996 to that in 1999?
Offer a very short reply. 1.58. What is the ratio of the CO2 emissions (% of total fuel combustion) of Algeria in 1996 to that in 2000?
Make the answer very short. 1.01. What is the ratio of the CO2 emissions (% of total fuel combustion) in Denmark in 1996 to that in 2000?
Your response must be concise. 0.7. What is the ratio of the CO2 emissions (% of total fuel combustion) of Hong Kong in 1996 to that in 2000?
Provide a short and direct response. 0.71. What is the ratio of the CO2 emissions (% of total fuel combustion) of Moldova in 1996 to that in 2000?
Make the answer very short. 1.47. What is the ratio of the CO2 emissions (% of total fuel combustion) in Algeria in 1997 to that in 1998?
Your answer should be compact. 0.99. What is the ratio of the CO2 emissions (% of total fuel combustion) in Denmark in 1997 to that in 1998?
Provide a short and direct response. 0.93. What is the ratio of the CO2 emissions (% of total fuel combustion) of Hong Kong in 1997 to that in 1998?
Keep it short and to the point. 0.77. What is the ratio of the CO2 emissions (% of total fuel combustion) of Moldova in 1997 to that in 1998?
Offer a terse response. 1.2. What is the ratio of the CO2 emissions (% of total fuel combustion) of Denmark in 1997 to that in 1999?
Provide a succinct answer. 0.88. What is the ratio of the CO2 emissions (% of total fuel combustion) of Hong Kong in 1997 to that in 1999?
Your answer should be very brief. 0.64. What is the ratio of the CO2 emissions (% of total fuel combustion) in Moldova in 1997 to that in 1999?
Provide a short and direct response. 1.46. What is the ratio of the CO2 emissions (% of total fuel combustion) of Algeria in 1997 to that in 2000?
Provide a succinct answer. 0.98. What is the ratio of the CO2 emissions (% of total fuel combustion) of Denmark in 1997 to that in 2000?
Give a very brief answer. 0.82. What is the ratio of the CO2 emissions (% of total fuel combustion) of Hong Kong in 1997 to that in 2000?
Ensure brevity in your answer.  0.77. What is the ratio of the CO2 emissions (% of total fuel combustion) in Moldova in 1997 to that in 2000?
Give a very brief answer. 1.36. What is the ratio of the CO2 emissions (% of total fuel combustion) of Denmark in 1998 to that in 1999?
Your answer should be very brief. 0.94. What is the ratio of the CO2 emissions (% of total fuel combustion) in Hong Kong in 1998 to that in 1999?
Your answer should be compact. 0.83. What is the ratio of the CO2 emissions (% of total fuel combustion) of Moldova in 1998 to that in 1999?
Keep it short and to the point. 1.21. What is the ratio of the CO2 emissions (% of total fuel combustion) of Algeria in 1998 to that in 2000?
Make the answer very short. 0.99. What is the ratio of the CO2 emissions (% of total fuel combustion) of Denmark in 1998 to that in 2000?
Keep it short and to the point. 0.88. What is the ratio of the CO2 emissions (% of total fuel combustion) of Hong Kong in 1998 to that in 2000?
Make the answer very short. 1. What is the ratio of the CO2 emissions (% of total fuel combustion) in Moldova in 1998 to that in 2000?
Give a very brief answer. 1.13. What is the ratio of the CO2 emissions (% of total fuel combustion) of Algeria in 1999 to that in 2000?
Your answer should be compact. 0.99. What is the ratio of the CO2 emissions (% of total fuel combustion) in Denmark in 1999 to that in 2000?
Give a very brief answer. 0.93. What is the ratio of the CO2 emissions (% of total fuel combustion) of Hong Kong in 1999 to that in 2000?
Provide a short and direct response. 1.2. What is the ratio of the CO2 emissions (% of total fuel combustion) in Moldova in 1999 to that in 2000?
Offer a very short reply. 0.93. What is the difference between the highest and the second highest CO2 emissions (% of total fuel combustion) in Algeria?
Offer a terse response. 0.08. What is the difference between the highest and the second highest CO2 emissions (% of total fuel combustion) of Denmark?
Your response must be concise. 1.6. What is the difference between the highest and the second highest CO2 emissions (% of total fuel combustion) of Hong Kong?
Provide a succinct answer. 5.69. What is the difference between the highest and the second highest CO2 emissions (% of total fuel combustion) in Moldova?
Make the answer very short. 0.87. What is the difference between the highest and the lowest CO2 emissions (% of total fuel combustion) of Algeria?
Your answer should be compact. 0.62. What is the difference between the highest and the lowest CO2 emissions (% of total fuel combustion) in Denmark?
Your response must be concise. 7. What is the difference between the highest and the lowest CO2 emissions (% of total fuel combustion) in Hong Kong?
Give a very brief answer. 14.07. What is the difference between the highest and the lowest CO2 emissions (% of total fuel combustion) in Moldova?
Provide a succinct answer. 4.16. 